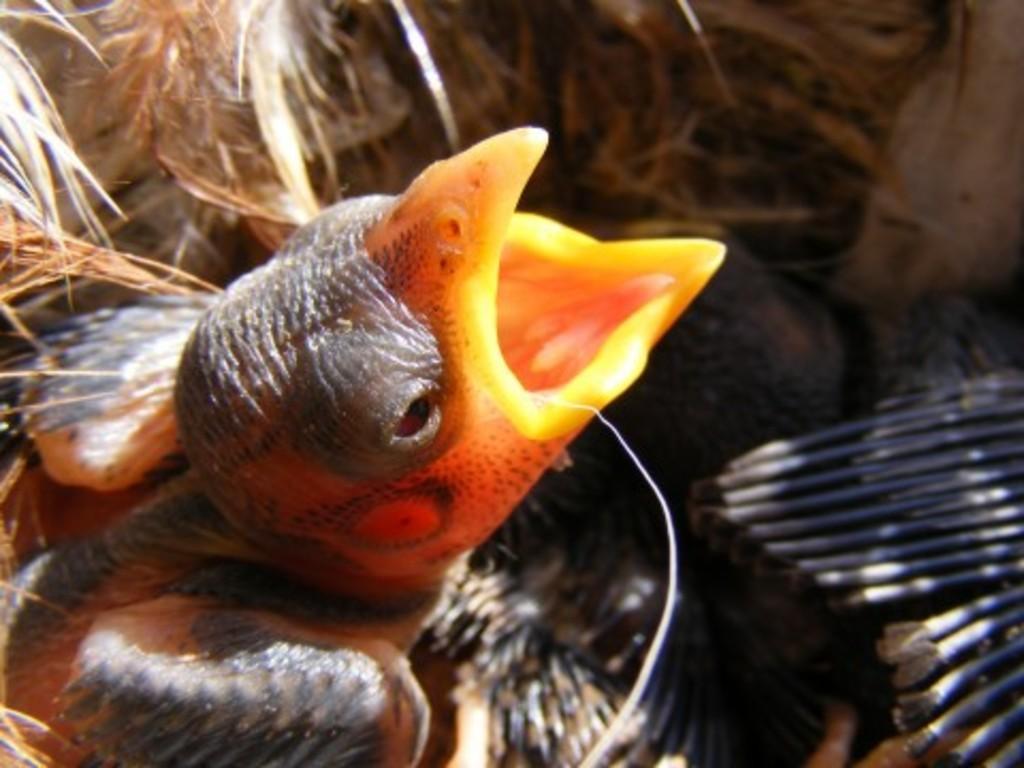Could you give a brief overview of what you see in this image? In this image I can see a bird in the front. On the right side of the image I can see few black colour things and on the top side of the image I can see dry grass. 